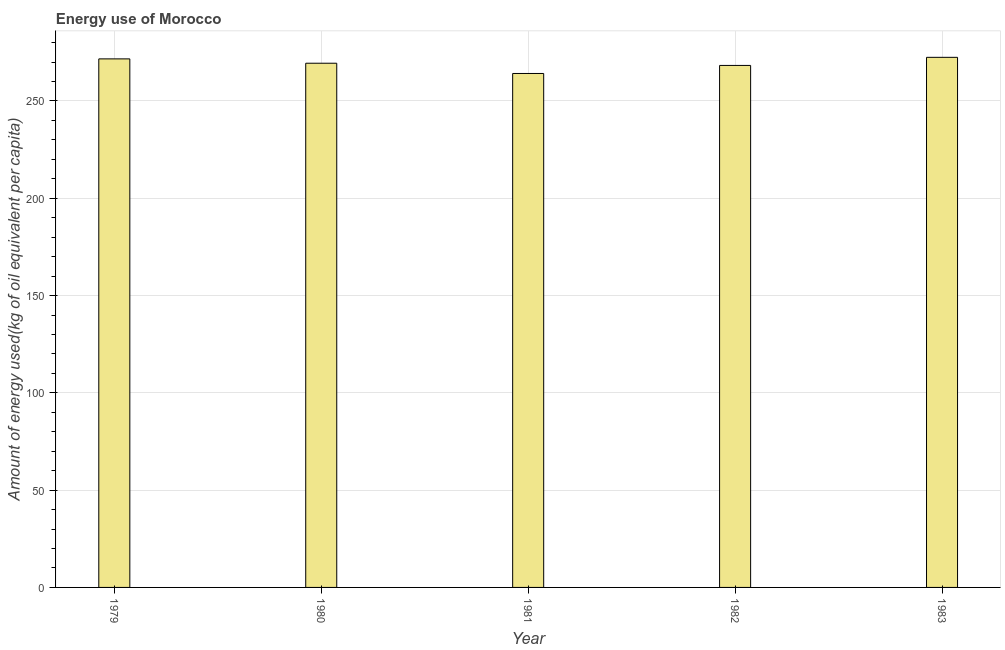Does the graph contain any zero values?
Your response must be concise. No. Does the graph contain grids?
Keep it short and to the point. Yes. What is the title of the graph?
Ensure brevity in your answer.  Energy use of Morocco. What is the label or title of the X-axis?
Your response must be concise. Year. What is the label or title of the Y-axis?
Provide a succinct answer. Amount of energy used(kg of oil equivalent per capita). What is the amount of energy used in 1983?
Ensure brevity in your answer.  272.42. Across all years, what is the maximum amount of energy used?
Keep it short and to the point. 272.42. Across all years, what is the minimum amount of energy used?
Offer a very short reply. 264.12. In which year was the amount of energy used maximum?
Your response must be concise. 1983. What is the sum of the amount of energy used?
Provide a short and direct response. 1345.81. What is the difference between the amount of energy used in 1980 and 1981?
Offer a very short reply. 5.27. What is the average amount of energy used per year?
Ensure brevity in your answer.  269.16. What is the median amount of energy used?
Make the answer very short. 269.39. What is the difference between the highest and the second highest amount of energy used?
Your answer should be compact. 0.8. Is the sum of the amount of energy used in 1979 and 1980 greater than the maximum amount of energy used across all years?
Your answer should be very brief. Yes. What is the difference between the highest and the lowest amount of energy used?
Make the answer very short. 8.3. How many bars are there?
Make the answer very short. 5. How many years are there in the graph?
Provide a succinct answer. 5. What is the Amount of energy used(kg of oil equivalent per capita) of 1979?
Provide a succinct answer. 271.62. What is the Amount of energy used(kg of oil equivalent per capita) of 1980?
Provide a succinct answer. 269.39. What is the Amount of energy used(kg of oil equivalent per capita) of 1981?
Keep it short and to the point. 264.12. What is the Amount of energy used(kg of oil equivalent per capita) in 1982?
Make the answer very short. 268.26. What is the Amount of energy used(kg of oil equivalent per capita) in 1983?
Ensure brevity in your answer.  272.42. What is the difference between the Amount of energy used(kg of oil equivalent per capita) in 1979 and 1980?
Give a very brief answer. 2.23. What is the difference between the Amount of energy used(kg of oil equivalent per capita) in 1979 and 1981?
Your answer should be very brief. 7.51. What is the difference between the Amount of energy used(kg of oil equivalent per capita) in 1979 and 1982?
Your answer should be compact. 3.37. What is the difference between the Amount of energy used(kg of oil equivalent per capita) in 1979 and 1983?
Keep it short and to the point. -0.79. What is the difference between the Amount of energy used(kg of oil equivalent per capita) in 1980 and 1981?
Make the answer very short. 5.27. What is the difference between the Amount of energy used(kg of oil equivalent per capita) in 1980 and 1982?
Provide a short and direct response. 1.14. What is the difference between the Amount of energy used(kg of oil equivalent per capita) in 1980 and 1983?
Your response must be concise. -3.03. What is the difference between the Amount of energy used(kg of oil equivalent per capita) in 1981 and 1982?
Offer a terse response. -4.14. What is the difference between the Amount of energy used(kg of oil equivalent per capita) in 1981 and 1983?
Your response must be concise. -8.3. What is the difference between the Amount of energy used(kg of oil equivalent per capita) in 1982 and 1983?
Ensure brevity in your answer.  -4.16. What is the ratio of the Amount of energy used(kg of oil equivalent per capita) in 1979 to that in 1981?
Your answer should be compact. 1.03. What is the ratio of the Amount of energy used(kg of oil equivalent per capita) in 1979 to that in 1982?
Ensure brevity in your answer.  1.01. What is the ratio of the Amount of energy used(kg of oil equivalent per capita) in 1979 to that in 1983?
Your answer should be compact. 1. What is the ratio of the Amount of energy used(kg of oil equivalent per capita) in 1980 to that in 1981?
Make the answer very short. 1.02. What is the ratio of the Amount of energy used(kg of oil equivalent per capita) in 1980 to that in 1982?
Your response must be concise. 1. What is the ratio of the Amount of energy used(kg of oil equivalent per capita) in 1980 to that in 1983?
Provide a short and direct response. 0.99. What is the ratio of the Amount of energy used(kg of oil equivalent per capita) in 1982 to that in 1983?
Your answer should be compact. 0.98. 